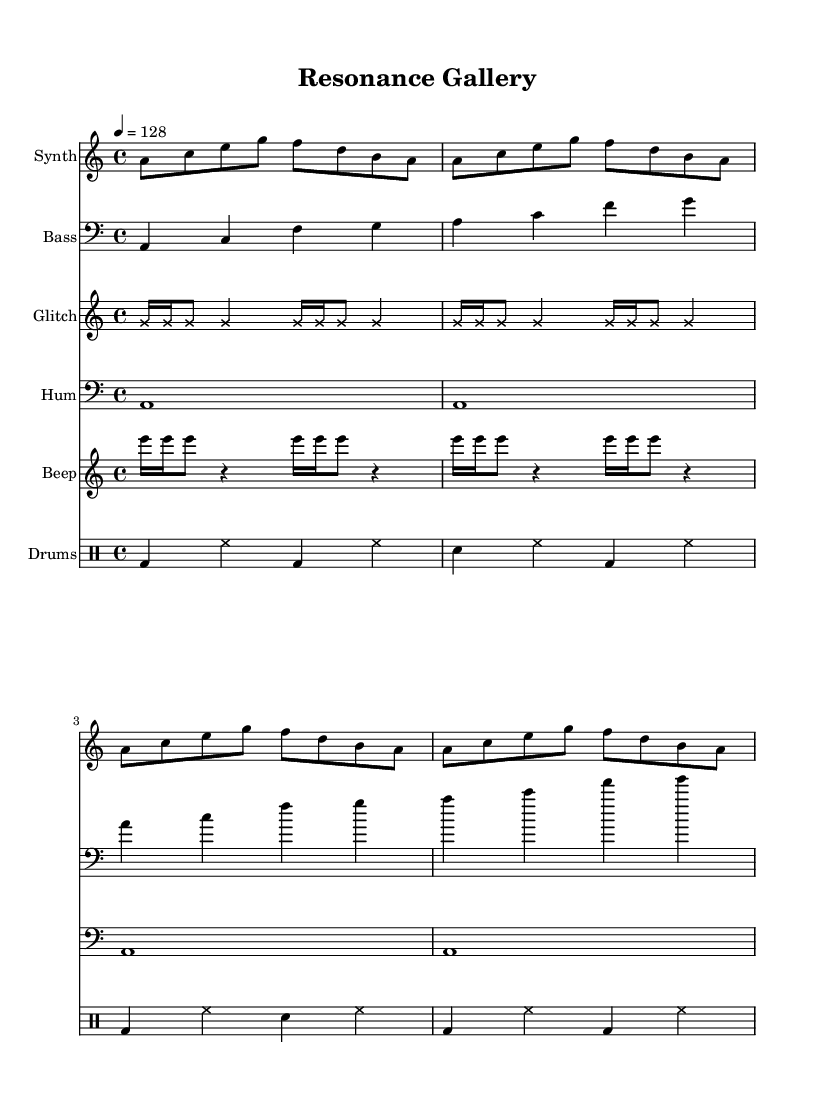What is the key signature of this music? The key signature is indicated at the beginning of the staff, showing it is in A minor, which has no sharps or flats.
Answer: A minor What is the time signature of the piece? The time signature is found at the beginning of the score; it indicates 4/4, meaning there are four beats in each measure and the quarter note gets one beat.
Answer: 4/4 What is the tempo marking? The tempo marking is indicated as quarter note equals 128 beats per minute, located at the beginning of the score under the global section.
Answer: 128 How many measures are in the synth part? By counting the measures in the synth line, eight measures are visible, each containing an equal amount of eighth notes and indicating a repeated pattern.
Answer: 8 Which instrument has pitch glitched sounds? The glitched sounds are produced by the "Glitch" instrument, which is notated with cross note heads, indicating a different sound texture.
Answer: Glitch What rhythmic pattern is used in the drums? The drums follow a typical four-pattern beat, alternating between bass drum, snare, and hi-hat, creating a steady rhythm commonly used in house music.
Answer: BD, HH, SN What sound does the projector produce? The projector produces a hum, indicated by whole notes in the "Hum" part, which suggests a constant sound throughout the measures.
Answer: Hum 